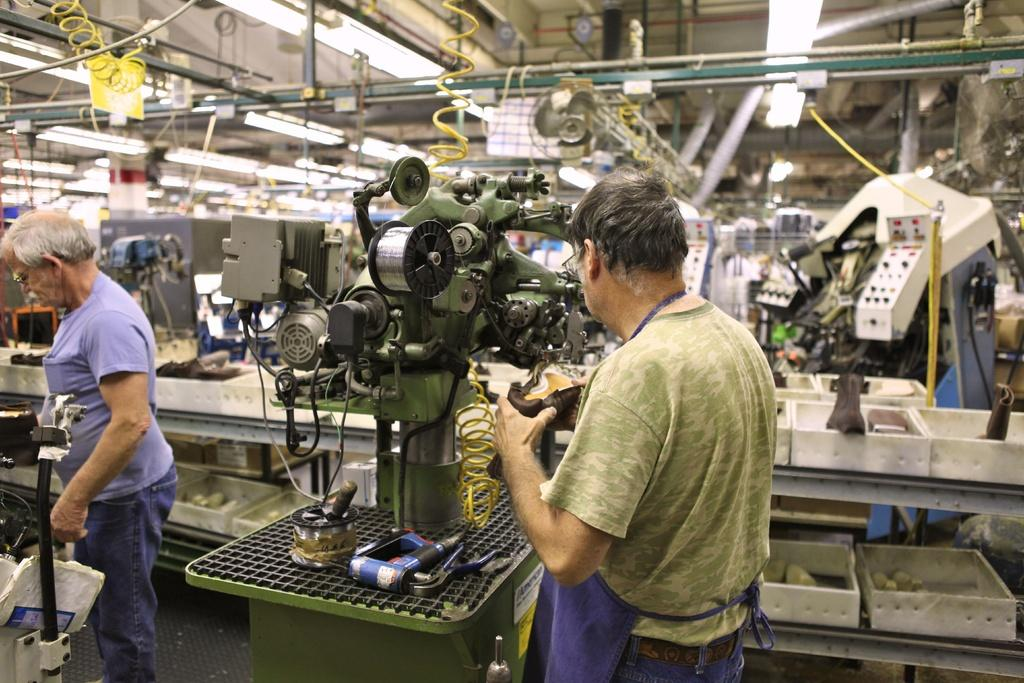How many people are in the image? There are two men standing in the image. What else can be seen in the image besides the men? There are machines and a fan in the image. What type of army is present in the image? There is no army present in the image; it features two men and some machines. What is the body language of the men in the image? The provided facts do not give information about the body language of the men, so we cannot answer this question. 